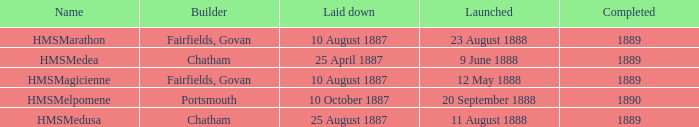When did chatham complete the Hmsmedusa? 1889.0. 